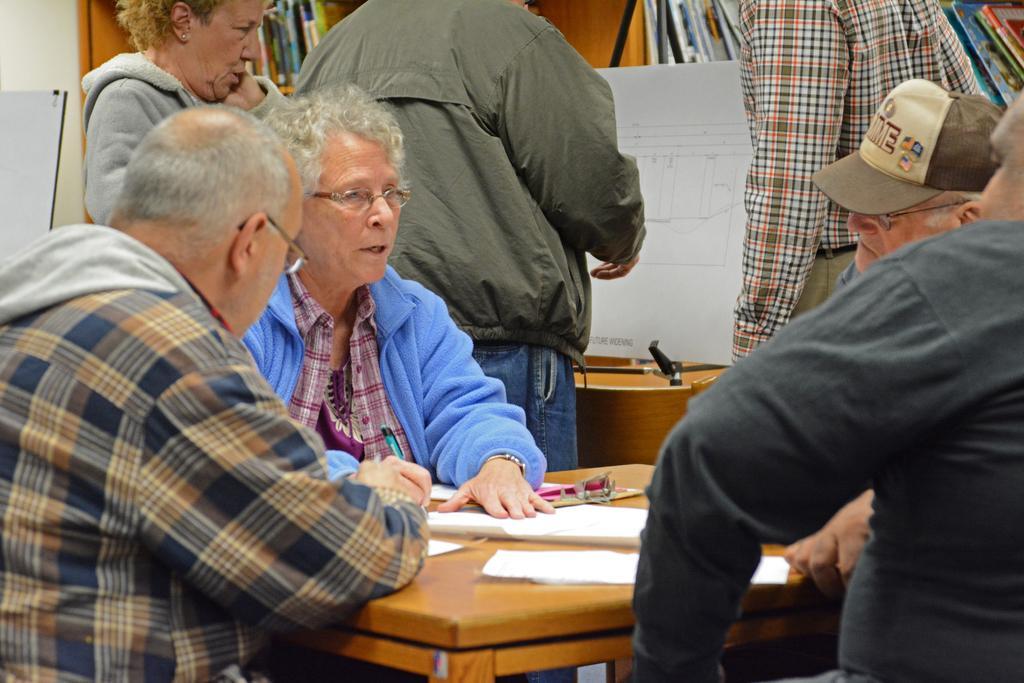Could you give a brief overview of what you see in this image? This Image consists of some people and there is a table in the middle. On that table there is paper pen and pad. People are sitting around the table and some people are standing. There is a chat in the middle and there are books in the racks. 